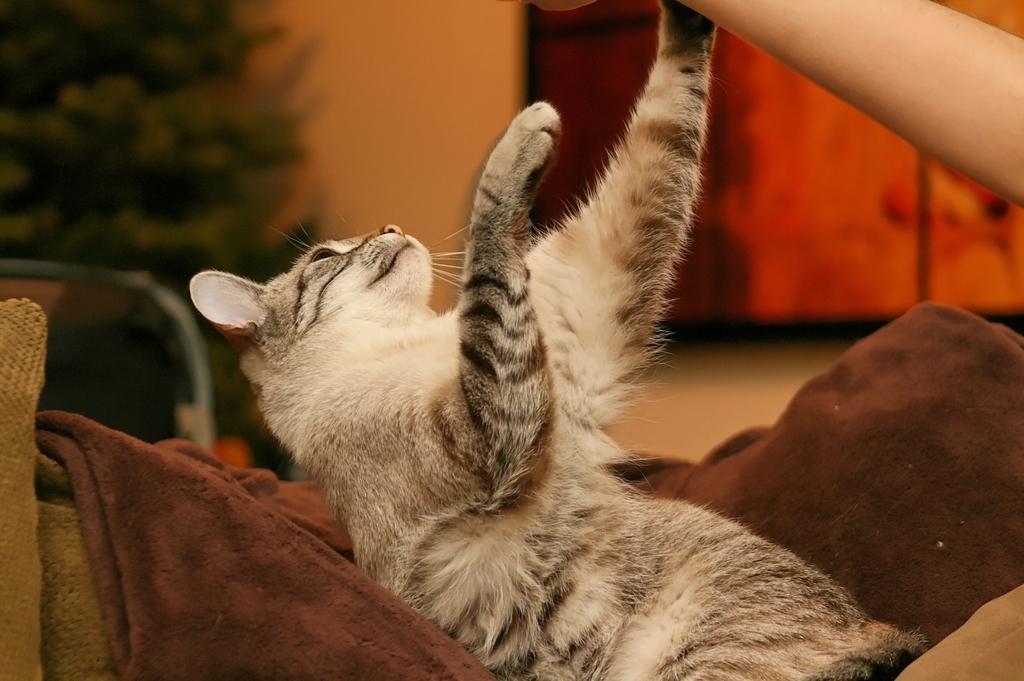In one or two sentences, can you explain what this image depicts? This picture shows a cat and we see a human hand and a blanket and a tree on the side. We see a cushion. 